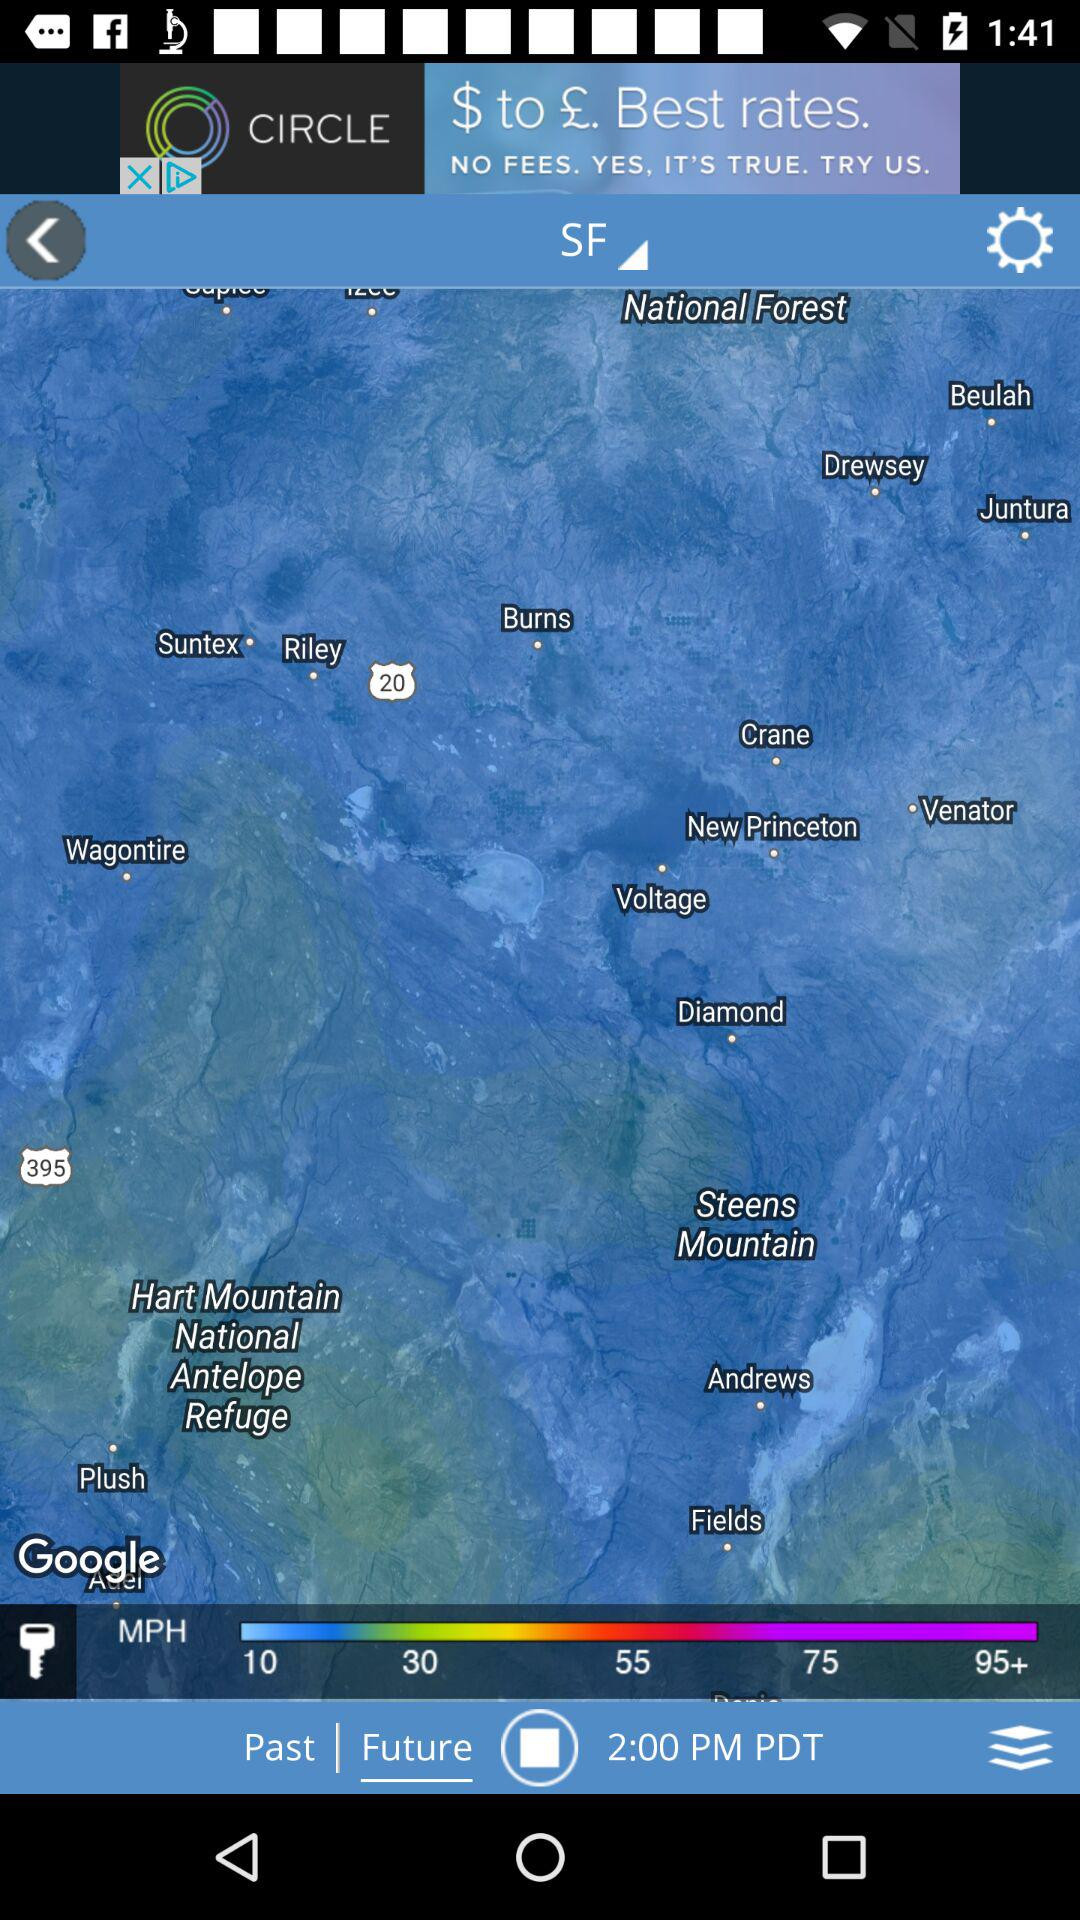How many MPH options are greater than 30?
Answer the question using a single word or phrase. 3 